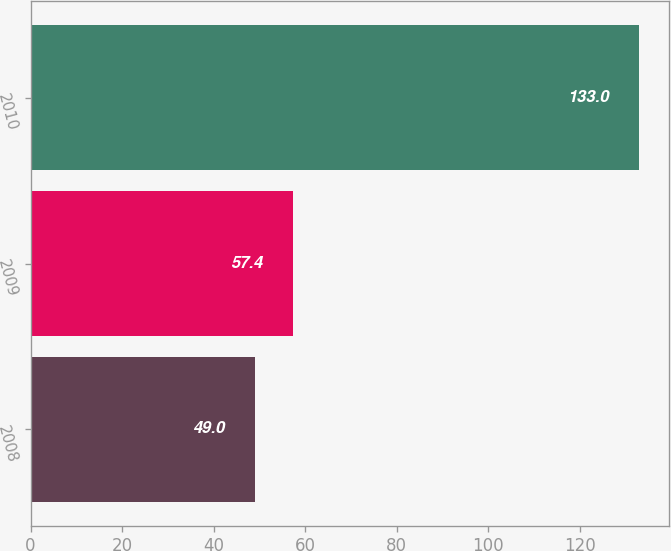<chart> <loc_0><loc_0><loc_500><loc_500><bar_chart><fcel>2008<fcel>2009<fcel>2010<nl><fcel>49<fcel>57.4<fcel>133<nl></chart> 